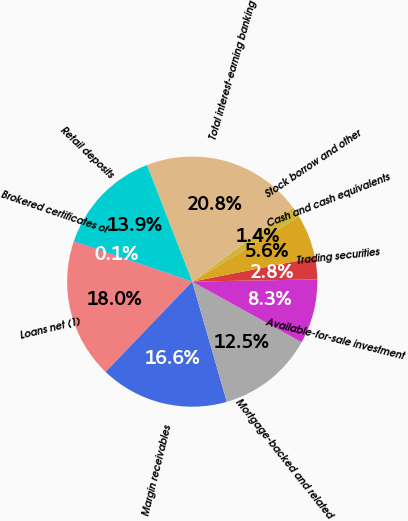Convert chart. <chart><loc_0><loc_0><loc_500><loc_500><pie_chart><fcel>Loans net (1)<fcel>Margin receivables<fcel>Mortgage-backed and related<fcel>Available-for-sale investment<fcel>Trading securities<fcel>Cash and cash equivalents<fcel>Stock borrow and other<fcel>Total interest-earning banking<fcel>Retail deposits<fcel>Brokered certificates of<nl><fcel>18.01%<fcel>16.63%<fcel>12.49%<fcel>8.34%<fcel>2.82%<fcel>5.58%<fcel>1.44%<fcel>20.77%<fcel>13.87%<fcel>0.06%<nl></chart> 